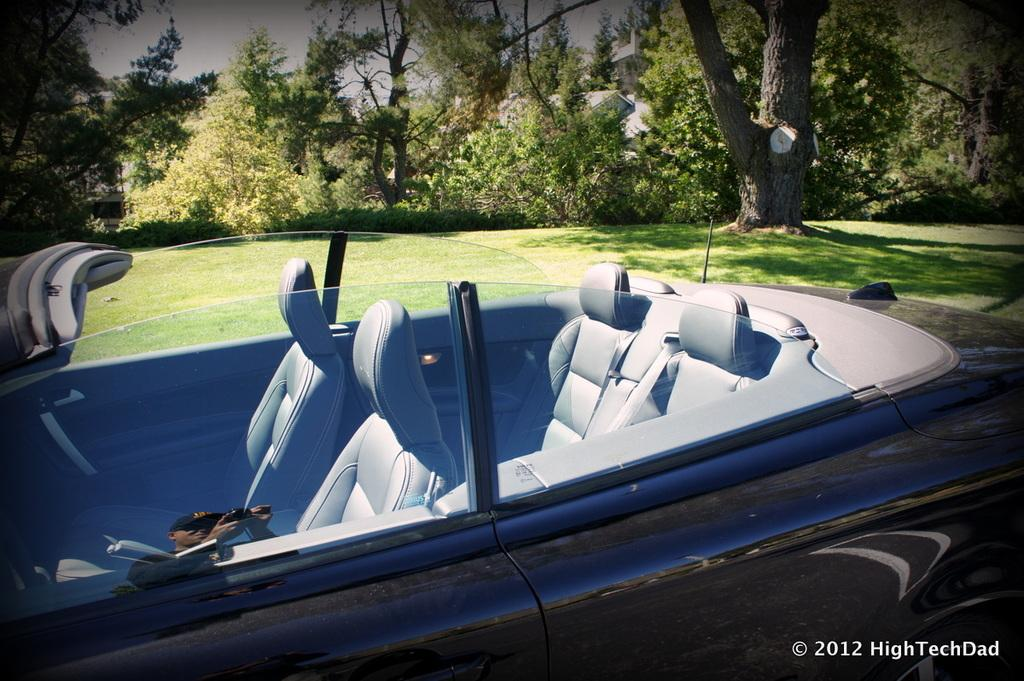What color is the car in the image? The car in the image is black. Where is the car located in the image? The car is at the bottom of the image. What can be seen in the background of the image? There are trees in the background of the image. What type of vegetation is visible in the image? There is grass visible in the image. What is present at the bottom of the image besides the car? There is some text at the bottom of the image. How many rabbits can be seen hopping on the rock in the image? There are no rabbits or rocks present in the image. 